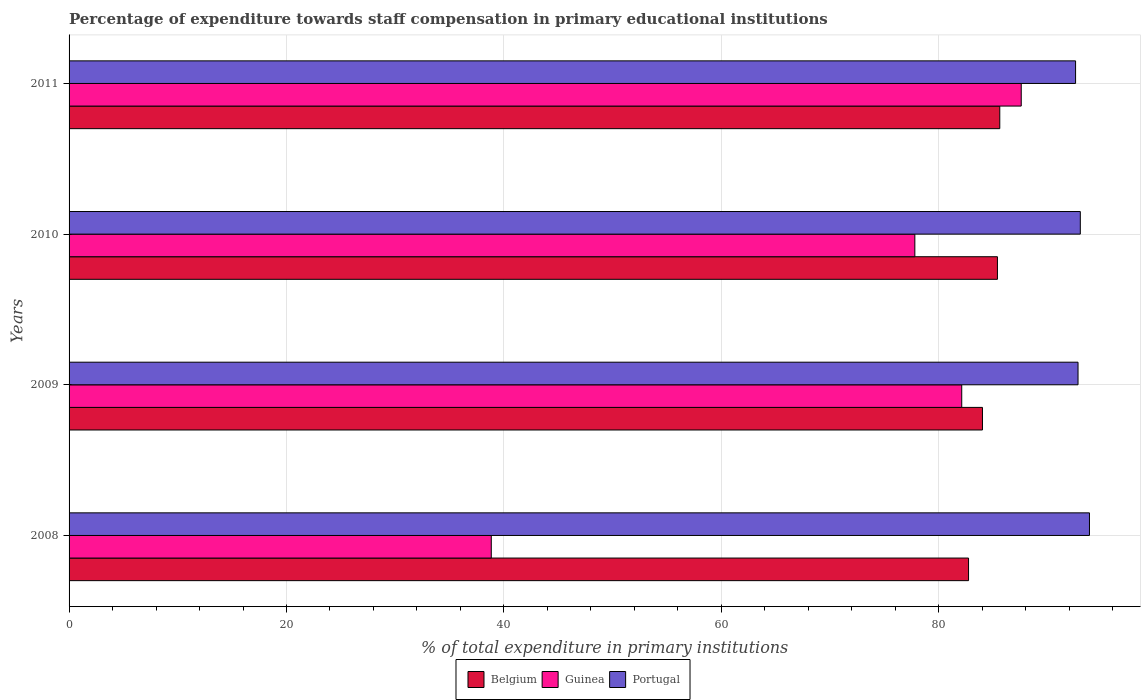Are the number of bars on each tick of the Y-axis equal?
Offer a very short reply. Yes. How many bars are there on the 3rd tick from the bottom?
Offer a very short reply. 3. What is the label of the 2nd group of bars from the top?
Offer a terse response. 2010. What is the percentage of expenditure towards staff compensation in Guinea in 2008?
Provide a succinct answer. 38.84. Across all years, what is the maximum percentage of expenditure towards staff compensation in Guinea?
Your answer should be very brief. 87.59. Across all years, what is the minimum percentage of expenditure towards staff compensation in Belgium?
Give a very brief answer. 82.74. What is the total percentage of expenditure towards staff compensation in Belgium in the graph?
Provide a short and direct response. 337.79. What is the difference between the percentage of expenditure towards staff compensation in Belgium in 2008 and that in 2009?
Ensure brevity in your answer.  -1.28. What is the difference between the percentage of expenditure towards staff compensation in Guinea in 2009 and the percentage of expenditure towards staff compensation in Belgium in 2008?
Keep it short and to the point. -0.63. What is the average percentage of expenditure towards staff compensation in Guinea per year?
Provide a succinct answer. 71.59. In the year 2008, what is the difference between the percentage of expenditure towards staff compensation in Portugal and percentage of expenditure towards staff compensation in Guinea?
Offer a terse response. 55.03. What is the ratio of the percentage of expenditure towards staff compensation in Belgium in 2009 to that in 2011?
Provide a short and direct response. 0.98. What is the difference between the highest and the second highest percentage of expenditure towards staff compensation in Belgium?
Your answer should be compact. 0.22. What is the difference between the highest and the lowest percentage of expenditure towards staff compensation in Portugal?
Provide a short and direct response. 1.28. What does the 2nd bar from the top in 2010 represents?
Keep it short and to the point. Guinea. Is it the case that in every year, the sum of the percentage of expenditure towards staff compensation in Portugal and percentage of expenditure towards staff compensation in Guinea is greater than the percentage of expenditure towards staff compensation in Belgium?
Offer a terse response. Yes. How many bars are there?
Provide a succinct answer. 12. Does the graph contain any zero values?
Your answer should be very brief. No. Does the graph contain grids?
Your answer should be very brief. Yes. Where does the legend appear in the graph?
Provide a short and direct response. Bottom center. How many legend labels are there?
Your response must be concise. 3. What is the title of the graph?
Offer a very short reply. Percentage of expenditure towards staff compensation in primary educational institutions. Does "Northern Mariana Islands" appear as one of the legend labels in the graph?
Make the answer very short. No. What is the label or title of the X-axis?
Ensure brevity in your answer.  % of total expenditure in primary institutions. What is the % of total expenditure in primary institutions in Belgium in 2008?
Provide a succinct answer. 82.74. What is the % of total expenditure in primary institutions of Guinea in 2008?
Your answer should be compact. 38.84. What is the % of total expenditure in primary institutions of Portugal in 2008?
Provide a succinct answer. 93.87. What is the % of total expenditure in primary institutions of Belgium in 2009?
Give a very brief answer. 84.03. What is the % of total expenditure in primary institutions of Guinea in 2009?
Your answer should be compact. 82.12. What is the % of total expenditure in primary institutions in Portugal in 2009?
Your response must be concise. 92.82. What is the % of total expenditure in primary institutions of Belgium in 2010?
Offer a terse response. 85.4. What is the % of total expenditure in primary institutions in Guinea in 2010?
Keep it short and to the point. 77.8. What is the % of total expenditure in primary institutions in Portugal in 2010?
Give a very brief answer. 93.03. What is the % of total expenditure in primary institutions of Belgium in 2011?
Your answer should be very brief. 85.62. What is the % of total expenditure in primary institutions of Guinea in 2011?
Your answer should be very brief. 87.59. What is the % of total expenditure in primary institutions of Portugal in 2011?
Your answer should be very brief. 92.59. Across all years, what is the maximum % of total expenditure in primary institutions in Belgium?
Your answer should be very brief. 85.62. Across all years, what is the maximum % of total expenditure in primary institutions in Guinea?
Keep it short and to the point. 87.59. Across all years, what is the maximum % of total expenditure in primary institutions of Portugal?
Your response must be concise. 93.87. Across all years, what is the minimum % of total expenditure in primary institutions of Belgium?
Provide a succinct answer. 82.74. Across all years, what is the minimum % of total expenditure in primary institutions in Guinea?
Provide a short and direct response. 38.84. Across all years, what is the minimum % of total expenditure in primary institutions of Portugal?
Keep it short and to the point. 92.59. What is the total % of total expenditure in primary institutions in Belgium in the graph?
Offer a terse response. 337.79. What is the total % of total expenditure in primary institutions in Guinea in the graph?
Provide a short and direct response. 286.35. What is the total % of total expenditure in primary institutions of Portugal in the graph?
Provide a succinct answer. 372.3. What is the difference between the % of total expenditure in primary institutions in Belgium in 2008 and that in 2009?
Offer a very short reply. -1.28. What is the difference between the % of total expenditure in primary institutions in Guinea in 2008 and that in 2009?
Offer a very short reply. -43.28. What is the difference between the % of total expenditure in primary institutions in Portugal in 2008 and that in 2009?
Give a very brief answer. 1.05. What is the difference between the % of total expenditure in primary institutions in Belgium in 2008 and that in 2010?
Your answer should be very brief. -2.66. What is the difference between the % of total expenditure in primary institutions in Guinea in 2008 and that in 2010?
Offer a terse response. -38.97. What is the difference between the % of total expenditure in primary institutions of Portugal in 2008 and that in 2010?
Give a very brief answer. 0.84. What is the difference between the % of total expenditure in primary institutions of Belgium in 2008 and that in 2011?
Your answer should be very brief. -2.87. What is the difference between the % of total expenditure in primary institutions in Guinea in 2008 and that in 2011?
Your answer should be compact. -48.75. What is the difference between the % of total expenditure in primary institutions of Portugal in 2008 and that in 2011?
Your response must be concise. 1.28. What is the difference between the % of total expenditure in primary institutions in Belgium in 2009 and that in 2010?
Provide a short and direct response. -1.38. What is the difference between the % of total expenditure in primary institutions of Guinea in 2009 and that in 2010?
Your answer should be compact. 4.31. What is the difference between the % of total expenditure in primary institutions of Portugal in 2009 and that in 2010?
Your response must be concise. -0.21. What is the difference between the % of total expenditure in primary institutions of Belgium in 2009 and that in 2011?
Your answer should be very brief. -1.59. What is the difference between the % of total expenditure in primary institutions of Guinea in 2009 and that in 2011?
Make the answer very short. -5.47. What is the difference between the % of total expenditure in primary institutions of Portugal in 2009 and that in 2011?
Give a very brief answer. 0.23. What is the difference between the % of total expenditure in primary institutions in Belgium in 2010 and that in 2011?
Your answer should be compact. -0.22. What is the difference between the % of total expenditure in primary institutions of Guinea in 2010 and that in 2011?
Your response must be concise. -9.79. What is the difference between the % of total expenditure in primary institutions in Portugal in 2010 and that in 2011?
Ensure brevity in your answer.  0.44. What is the difference between the % of total expenditure in primary institutions in Belgium in 2008 and the % of total expenditure in primary institutions in Guinea in 2009?
Offer a very short reply. 0.63. What is the difference between the % of total expenditure in primary institutions in Belgium in 2008 and the % of total expenditure in primary institutions in Portugal in 2009?
Give a very brief answer. -10.07. What is the difference between the % of total expenditure in primary institutions in Guinea in 2008 and the % of total expenditure in primary institutions in Portugal in 2009?
Offer a terse response. -53.98. What is the difference between the % of total expenditure in primary institutions in Belgium in 2008 and the % of total expenditure in primary institutions in Guinea in 2010?
Provide a succinct answer. 4.94. What is the difference between the % of total expenditure in primary institutions of Belgium in 2008 and the % of total expenditure in primary institutions of Portugal in 2010?
Offer a very short reply. -10.28. What is the difference between the % of total expenditure in primary institutions in Guinea in 2008 and the % of total expenditure in primary institutions in Portugal in 2010?
Give a very brief answer. -54.19. What is the difference between the % of total expenditure in primary institutions in Belgium in 2008 and the % of total expenditure in primary institutions in Guinea in 2011?
Make the answer very short. -4.85. What is the difference between the % of total expenditure in primary institutions of Belgium in 2008 and the % of total expenditure in primary institutions of Portugal in 2011?
Give a very brief answer. -9.85. What is the difference between the % of total expenditure in primary institutions of Guinea in 2008 and the % of total expenditure in primary institutions of Portugal in 2011?
Offer a terse response. -53.75. What is the difference between the % of total expenditure in primary institutions of Belgium in 2009 and the % of total expenditure in primary institutions of Guinea in 2010?
Give a very brief answer. 6.22. What is the difference between the % of total expenditure in primary institutions in Belgium in 2009 and the % of total expenditure in primary institutions in Portugal in 2010?
Give a very brief answer. -9. What is the difference between the % of total expenditure in primary institutions of Guinea in 2009 and the % of total expenditure in primary institutions of Portugal in 2010?
Make the answer very short. -10.91. What is the difference between the % of total expenditure in primary institutions in Belgium in 2009 and the % of total expenditure in primary institutions in Guinea in 2011?
Offer a terse response. -3.57. What is the difference between the % of total expenditure in primary institutions in Belgium in 2009 and the % of total expenditure in primary institutions in Portugal in 2011?
Provide a succinct answer. -8.56. What is the difference between the % of total expenditure in primary institutions of Guinea in 2009 and the % of total expenditure in primary institutions of Portugal in 2011?
Give a very brief answer. -10.47. What is the difference between the % of total expenditure in primary institutions in Belgium in 2010 and the % of total expenditure in primary institutions in Guinea in 2011?
Your answer should be compact. -2.19. What is the difference between the % of total expenditure in primary institutions of Belgium in 2010 and the % of total expenditure in primary institutions of Portugal in 2011?
Your response must be concise. -7.19. What is the difference between the % of total expenditure in primary institutions of Guinea in 2010 and the % of total expenditure in primary institutions of Portugal in 2011?
Your response must be concise. -14.79. What is the average % of total expenditure in primary institutions in Belgium per year?
Offer a very short reply. 84.45. What is the average % of total expenditure in primary institutions in Guinea per year?
Make the answer very short. 71.59. What is the average % of total expenditure in primary institutions in Portugal per year?
Provide a short and direct response. 93.08. In the year 2008, what is the difference between the % of total expenditure in primary institutions in Belgium and % of total expenditure in primary institutions in Guinea?
Ensure brevity in your answer.  43.9. In the year 2008, what is the difference between the % of total expenditure in primary institutions of Belgium and % of total expenditure in primary institutions of Portugal?
Make the answer very short. -11.12. In the year 2008, what is the difference between the % of total expenditure in primary institutions in Guinea and % of total expenditure in primary institutions in Portugal?
Your answer should be compact. -55.03. In the year 2009, what is the difference between the % of total expenditure in primary institutions of Belgium and % of total expenditure in primary institutions of Guinea?
Your answer should be very brief. 1.91. In the year 2009, what is the difference between the % of total expenditure in primary institutions in Belgium and % of total expenditure in primary institutions in Portugal?
Make the answer very short. -8.79. In the year 2009, what is the difference between the % of total expenditure in primary institutions of Guinea and % of total expenditure in primary institutions of Portugal?
Keep it short and to the point. -10.7. In the year 2010, what is the difference between the % of total expenditure in primary institutions in Belgium and % of total expenditure in primary institutions in Guinea?
Give a very brief answer. 7.6. In the year 2010, what is the difference between the % of total expenditure in primary institutions in Belgium and % of total expenditure in primary institutions in Portugal?
Provide a short and direct response. -7.62. In the year 2010, what is the difference between the % of total expenditure in primary institutions in Guinea and % of total expenditure in primary institutions in Portugal?
Provide a short and direct response. -15.22. In the year 2011, what is the difference between the % of total expenditure in primary institutions in Belgium and % of total expenditure in primary institutions in Guinea?
Your answer should be compact. -1.97. In the year 2011, what is the difference between the % of total expenditure in primary institutions of Belgium and % of total expenditure in primary institutions of Portugal?
Your answer should be compact. -6.97. In the year 2011, what is the difference between the % of total expenditure in primary institutions in Guinea and % of total expenditure in primary institutions in Portugal?
Your answer should be very brief. -5. What is the ratio of the % of total expenditure in primary institutions of Belgium in 2008 to that in 2009?
Keep it short and to the point. 0.98. What is the ratio of the % of total expenditure in primary institutions of Guinea in 2008 to that in 2009?
Make the answer very short. 0.47. What is the ratio of the % of total expenditure in primary institutions in Portugal in 2008 to that in 2009?
Make the answer very short. 1.01. What is the ratio of the % of total expenditure in primary institutions of Belgium in 2008 to that in 2010?
Your answer should be compact. 0.97. What is the ratio of the % of total expenditure in primary institutions in Guinea in 2008 to that in 2010?
Provide a short and direct response. 0.5. What is the ratio of the % of total expenditure in primary institutions in Portugal in 2008 to that in 2010?
Make the answer very short. 1.01. What is the ratio of the % of total expenditure in primary institutions of Belgium in 2008 to that in 2011?
Offer a terse response. 0.97. What is the ratio of the % of total expenditure in primary institutions in Guinea in 2008 to that in 2011?
Your answer should be compact. 0.44. What is the ratio of the % of total expenditure in primary institutions in Portugal in 2008 to that in 2011?
Give a very brief answer. 1.01. What is the ratio of the % of total expenditure in primary institutions of Belgium in 2009 to that in 2010?
Your response must be concise. 0.98. What is the ratio of the % of total expenditure in primary institutions of Guinea in 2009 to that in 2010?
Keep it short and to the point. 1.06. What is the ratio of the % of total expenditure in primary institutions in Portugal in 2009 to that in 2010?
Offer a very short reply. 1. What is the ratio of the % of total expenditure in primary institutions of Belgium in 2009 to that in 2011?
Provide a short and direct response. 0.98. What is the ratio of the % of total expenditure in primary institutions in Guinea in 2009 to that in 2011?
Your answer should be compact. 0.94. What is the ratio of the % of total expenditure in primary institutions in Portugal in 2009 to that in 2011?
Keep it short and to the point. 1. What is the ratio of the % of total expenditure in primary institutions of Guinea in 2010 to that in 2011?
Your response must be concise. 0.89. What is the difference between the highest and the second highest % of total expenditure in primary institutions in Belgium?
Provide a short and direct response. 0.22. What is the difference between the highest and the second highest % of total expenditure in primary institutions in Guinea?
Offer a very short reply. 5.47. What is the difference between the highest and the second highest % of total expenditure in primary institutions of Portugal?
Provide a succinct answer. 0.84. What is the difference between the highest and the lowest % of total expenditure in primary institutions of Belgium?
Offer a very short reply. 2.87. What is the difference between the highest and the lowest % of total expenditure in primary institutions of Guinea?
Offer a terse response. 48.75. What is the difference between the highest and the lowest % of total expenditure in primary institutions in Portugal?
Your answer should be compact. 1.28. 